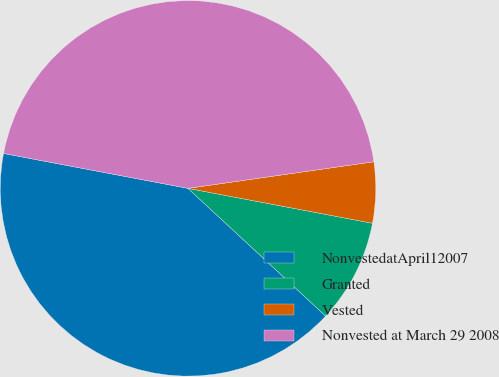<chart> <loc_0><loc_0><loc_500><loc_500><pie_chart><fcel>NonvestedatApril12007<fcel>Granted<fcel>Vested<fcel>Nonvested at March 29 2008<nl><fcel>41.07%<fcel>8.93%<fcel>5.24%<fcel>44.76%<nl></chart> 